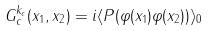<formula> <loc_0><loc_0><loc_500><loc_500>G _ { c } ^ { k _ { c } } ( x _ { 1 } , x _ { 2 } ) = i \langle P ( \varphi ( x _ { 1 } ) \varphi ( x _ { 2 } ) ) \rangle _ { 0 }</formula> 